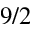<formula> <loc_0><loc_0><loc_500><loc_500>9 / 2</formula> 